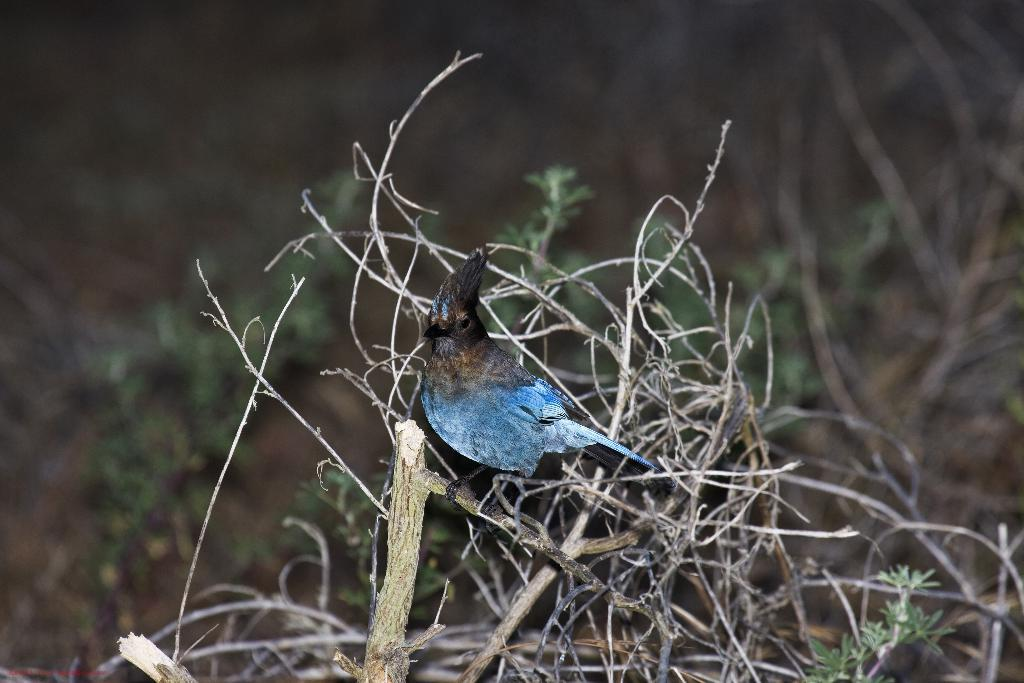What type of animal is in the image? There is a bird in the image. Where is the bird located? The bird is on a branch. What can be seen in the background of the image? There are leaves in the background of the image. How would you describe the background of the image? The background is blurry. Is there a volcano visible in the background of the image? No, there is no volcano present in the image. How does the bird move around in the image? The bird's movement is not visible in the image, as it appears to be perched on the branch. 